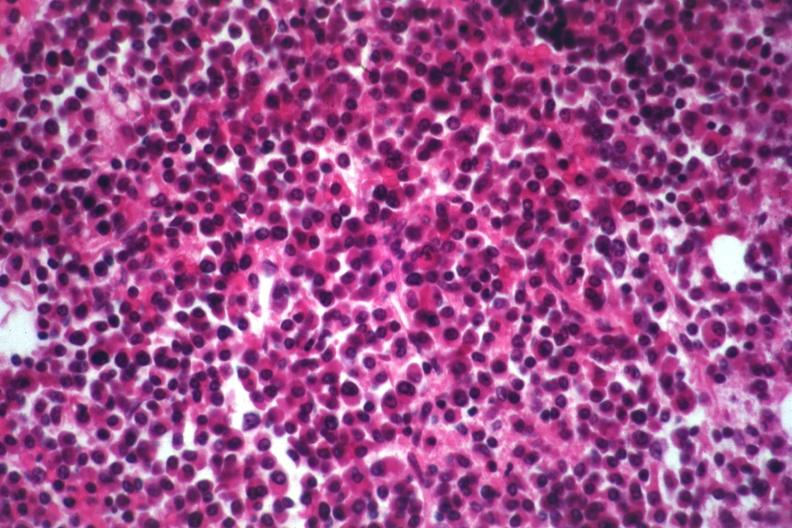s adenocarcinoma present?
Answer the question using a single word or phrase. No 